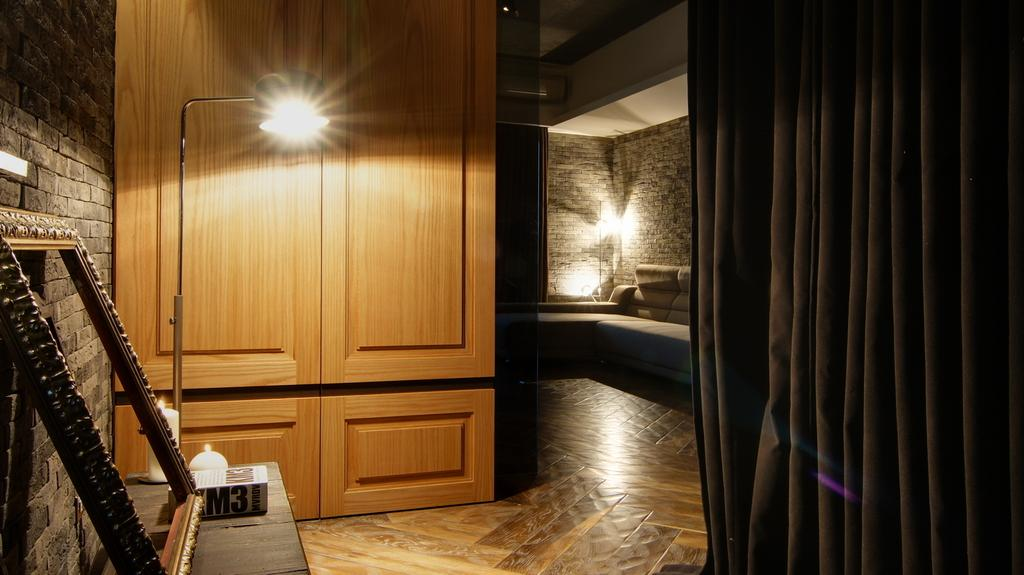What is the main structure in the image? There is a frame in the image. What piece of furniture is present in the image? There is a table, a couch, and a cupboard in the image. What type of window treatment is visible in the image? There is a curtain in the image. What lighting elements are present in the image? There are lights, a lamp, and candles in the image. What type of walls are visible in the image? There are walls in the image. Where is the train station located in the image? There is no train station present in the image. What type of hose is used to water the plants in the image? There are no plants or hoses present in the image. 